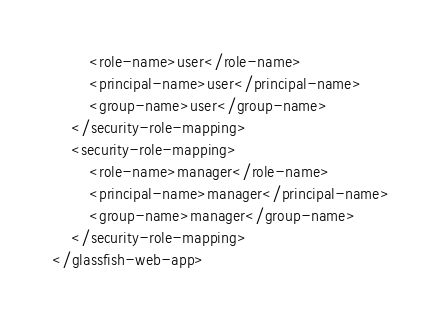Convert code to text. <code><loc_0><loc_0><loc_500><loc_500><_XML_>		<role-name>user</role-name>
		<principal-name>user</principal-name>
		<group-name>user</group-name>
	</security-role-mapping>
	<security-role-mapping>
		<role-name>manager</role-name>
		<principal-name>manager</principal-name>
		<group-name>manager</group-name>
	</security-role-mapping>
</glassfish-web-app></code> 